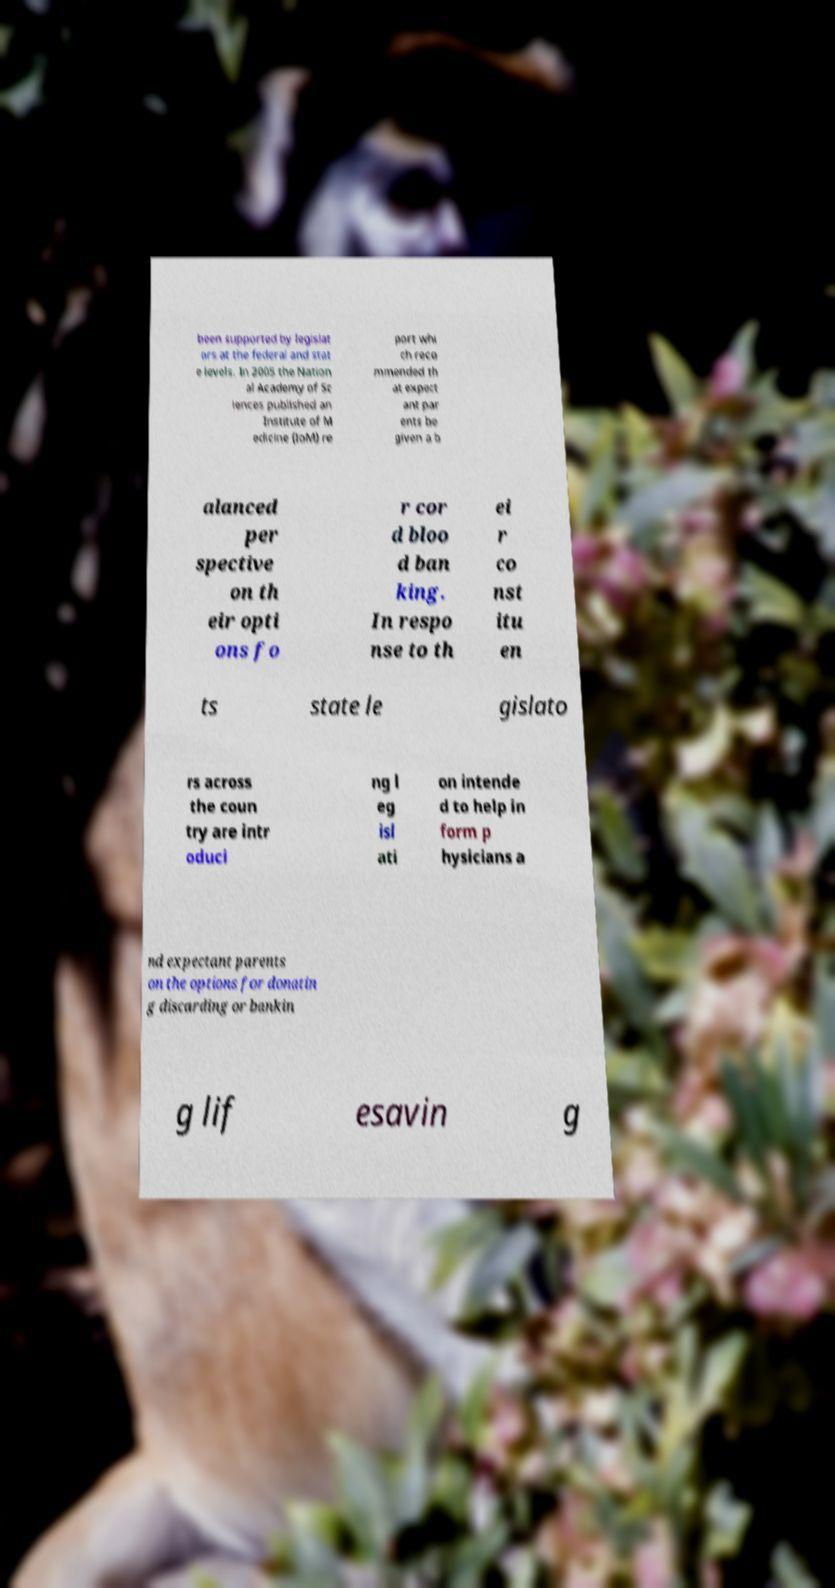Please identify and transcribe the text found in this image. been supported by legislat ors at the federal and stat e levels. In 2005 the Nation al Academy of Sc iences published an Institute of M edicine (IoM) re port whi ch reco mmended th at expect ant par ents be given a b alanced per spective on th eir opti ons fo r cor d bloo d ban king. In respo nse to th ei r co nst itu en ts state le gislato rs across the coun try are intr oduci ng l eg isl ati on intende d to help in form p hysicians a nd expectant parents on the options for donatin g discarding or bankin g lif esavin g 